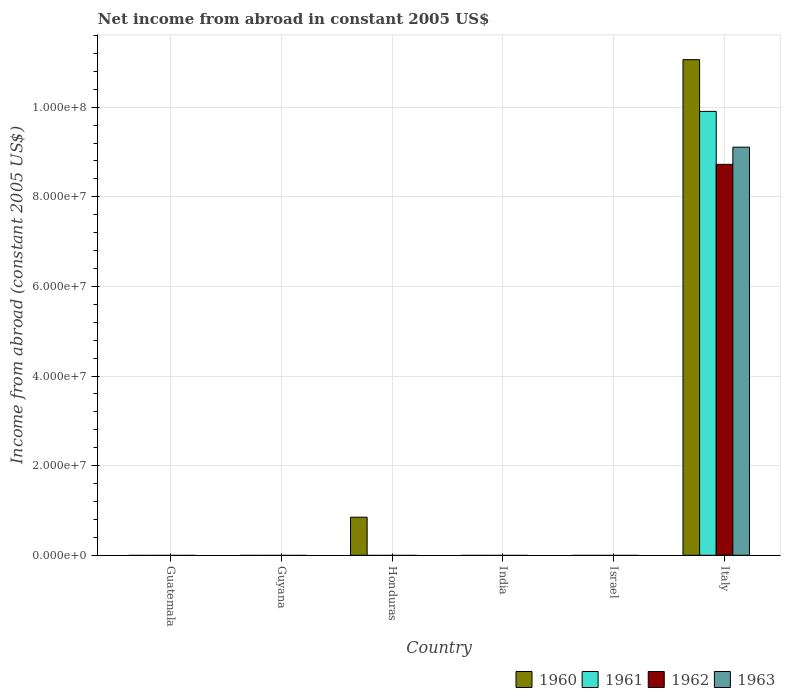Are the number of bars per tick equal to the number of legend labels?
Offer a very short reply. No. How many bars are there on the 5th tick from the right?
Give a very brief answer. 0. What is the label of the 5th group of bars from the left?
Your response must be concise. Israel. Across all countries, what is the maximum net income from abroad in 1961?
Offer a very short reply. 9.91e+07. What is the total net income from abroad in 1962 in the graph?
Give a very brief answer. 8.72e+07. What is the difference between the net income from abroad in 1961 in India and the net income from abroad in 1963 in Italy?
Ensure brevity in your answer.  -9.11e+07. What is the average net income from abroad in 1962 per country?
Give a very brief answer. 1.45e+07. In how many countries, is the net income from abroad in 1963 greater than 92000000 US$?
Provide a short and direct response. 0. What is the difference between the highest and the lowest net income from abroad in 1961?
Ensure brevity in your answer.  9.91e+07. In how many countries, is the net income from abroad in 1962 greater than the average net income from abroad in 1962 taken over all countries?
Your answer should be very brief. 1. Is it the case that in every country, the sum of the net income from abroad in 1961 and net income from abroad in 1960 is greater than the net income from abroad in 1962?
Give a very brief answer. No. How many bars are there?
Provide a succinct answer. 5. Are all the bars in the graph horizontal?
Keep it short and to the point. No. Are the values on the major ticks of Y-axis written in scientific E-notation?
Your answer should be very brief. Yes. Does the graph contain grids?
Keep it short and to the point. Yes. Where does the legend appear in the graph?
Offer a terse response. Bottom right. What is the title of the graph?
Your response must be concise. Net income from abroad in constant 2005 US$. What is the label or title of the X-axis?
Give a very brief answer. Country. What is the label or title of the Y-axis?
Keep it short and to the point. Income from abroad (constant 2005 US$). What is the Income from abroad (constant 2005 US$) of 1961 in Guatemala?
Keep it short and to the point. 0. What is the Income from abroad (constant 2005 US$) in 1962 in Guatemala?
Your answer should be very brief. 0. What is the Income from abroad (constant 2005 US$) in 1960 in Guyana?
Offer a very short reply. 0. What is the Income from abroad (constant 2005 US$) of 1961 in Guyana?
Offer a very short reply. 0. What is the Income from abroad (constant 2005 US$) of 1962 in Guyana?
Provide a short and direct response. 0. What is the Income from abroad (constant 2005 US$) of 1960 in Honduras?
Keep it short and to the point. 8.50e+06. What is the Income from abroad (constant 2005 US$) in 1962 in India?
Your response must be concise. 0. What is the Income from abroad (constant 2005 US$) of 1963 in India?
Your response must be concise. 0. What is the Income from abroad (constant 2005 US$) in 1961 in Israel?
Offer a terse response. 0. What is the Income from abroad (constant 2005 US$) in 1962 in Israel?
Provide a succinct answer. 0. What is the Income from abroad (constant 2005 US$) in 1963 in Israel?
Your answer should be compact. 0. What is the Income from abroad (constant 2005 US$) in 1960 in Italy?
Offer a very short reply. 1.11e+08. What is the Income from abroad (constant 2005 US$) of 1961 in Italy?
Your response must be concise. 9.91e+07. What is the Income from abroad (constant 2005 US$) in 1962 in Italy?
Offer a terse response. 8.72e+07. What is the Income from abroad (constant 2005 US$) in 1963 in Italy?
Your answer should be compact. 9.11e+07. Across all countries, what is the maximum Income from abroad (constant 2005 US$) of 1960?
Your response must be concise. 1.11e+08. Across all countries, what is the maximum Income from abroad (constant 2005 US$) in 1961?
Your response must be concise. 9.91e+07. Across all countries, what is the maximum Income from abroad (constant 2005 US$) in 1962?
Provide a succinct answer. 8.72e+07. Across all countries, what is the maximum Income from abroad (constant 2005 US$) of 1963?
Your response must be concise. 9.11e+07. Across all countries, what is the minimum Income from abroad (constant 2005 US$) in 1961?
Offer a very short reply. 0. Across all countries, what is the minimum Income from abroad (constant 2005 US$) in 1962?
Ensure brevity in your answer.  0. Across all countries, what is the minimum Income from abroad (constant 2005 US$) of 1963?
Provide a short and direct response. 0. What is the total Income from abroad (constant 2005 US$) in 1960 in the graph?
Make the answer very short. 1.19e+08. What is the total Income from abroad (constant 2005 US$) in 1961 in the graph?
Provide a short and direct response. 9.91e+07. What is the total Income from abroad (constant 2005 US$) in 1962 in the graph?
Offer a terse response. 8.72e+07. What is the total Income from abroad (constant 2005 US$) of 1963 in the graph?
Make the answer very short. 9.11e+07. What is the difference between the Income from abroad (constant 2005 US$) of 1960 in Honduras and that in Italy?
Your response must be concise. -1.02e+08. What is the difference between the Income from abroad (constant 2005 US$) in 1960 in Honduras and the Income from abroad (constant 2005 US$) in 1961 in Italy?
Offer a very short reply. -9.06e+07. What is the difference between the Income from abroad (constant 2005 US$) in 1960 in Honduras and the Income from abroad (constant 2005 US$) in 1962 in Italy?
Make the answer very short. -7.87e+07. What is the difference between the Income from abroad (constant 2005 US$) of 1960 in Honduras and the Income from abroad (constant 2005 US$) of 1963 in Italy?
Offer a terse response. -8.26e+07. What is the average Income from abroad (constant 2005 US$) of 1960 per country?
Make the answer very short. 1.99e+07. What is the average Income from abroad (constant 2005 US$) in 1961 per country?
Give a very brief answer. 1.65e+07. What is the average Income from abroad (constant 2005 US$) in 1962 per country?
Provide a succinct answer. 1.45e+07. What is the average Income from abroad (constant 2005 US$) in 1963 per country?
Your answer should be compact. 1.52e+07. What is the difference between the Income from abroad (constant 2005 US$) of 1960 and Income from abroad (constant 2005 US$) of 1961 in Italy?
Your answer should be very brief. 1.15e+07. What is the difference between the Income from abroad (constant 2005 US$) in 1960 and Income from abroad (constant 2005 US$) in 1962 in Italy?
Your answer should be compact. 2.34e+07. What is the difference between the Income from abroad (constant 2005 US$) of 1960 and Income from abroad (constant 2005 US$) of 1963 in Italy?
Keep it short and to the point. 1.95e+07. What is the difference between the Income from abroad (constant 2005 US$) of 1961 and Income from abroad (constant 2005 US$) of 1962 in Italy?
Ensure brevity in your answer.  1.18e+07. What is the difference between the Income from abroad (constant 2005 US$) in 1961 and Income from abroad (constant 2005 US$) in 1963 in Italy?
Make the answer very short. 7.98e+06. What is the difference between the Income from abroad (constant 2005 US$) in 1962 and Income from abroad (constant 2005 US$) in 1963 in Italy?
Your answer should be very brief. -3.84e+06. What is the ratio of the Income from abroad (constant 2005 US$) of 1960 in Honduras to that in Italy?
Offer a terse response. 0.08. What is the difference between the highest and the lowest Income from abroad (constant 2005 US$) of 1960?
Your answer should be very brief. 1.11e+08. What is the difference between the highest and the lowest Income from abroad (constant 2005 US$) in 1961?
Offer a terse response. 9.91e+07. What is the difference between the highest and the lowest Income from abroad (constant 2005 US$) of 1962?
Offer a very short reply. 8.72e+07. What is the difference between the highest and the lowest Income from abroad (constant 2005 US$) in 1963?
Make the answer very short. 9.11e+07. 